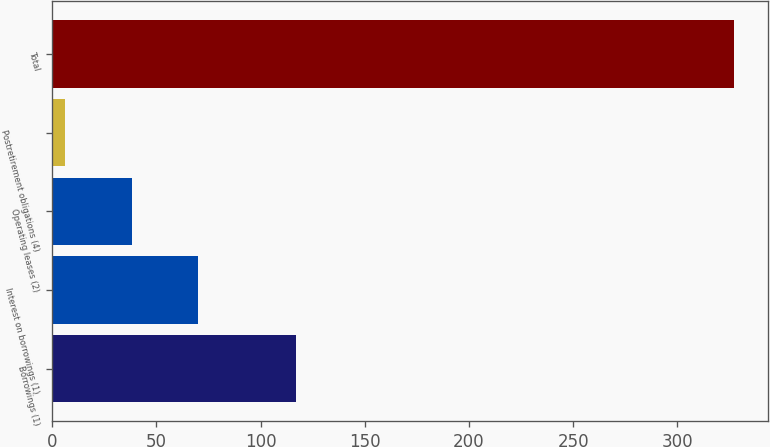Convert chart to OTSL. <chart><loc_0><loc_0><loc_500><loc_500><bar_chart><fcel>Borrowings (1)<fcel>Interest on borrowings (1)<fcel>Operating leases (2)<fcel>Postretirement obligations (4)<fcel>Total<nl><fcel>117<fcel>70.2<fcel>38.1<fcel>6<fcel>327<nl></chart> 